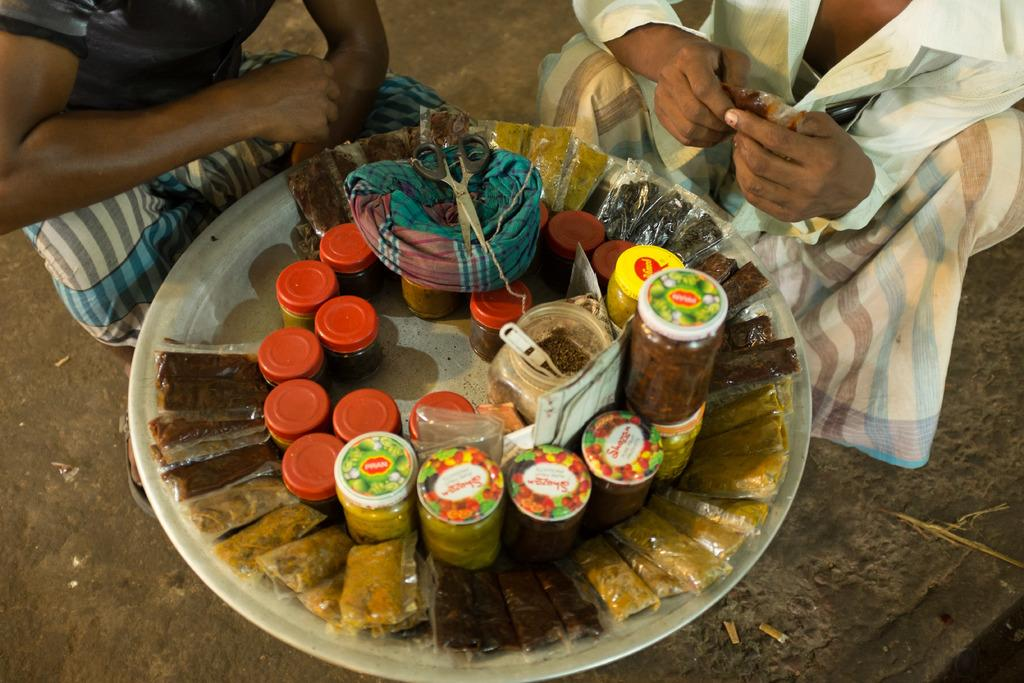What objects are in the foreground of the image? In the foreground of the image, there are sachets, containers, scissors, a cloth, and a metal object. What are the two people in the image doing? The two people in the image are squatting on the ground. What might the scissors be used for in the image? The scissors might be used for cutting or trimming in the image. How many eggs are visible in the image? There are no eggs visible in the image. What part of the wheel is shown in the image? There is no wheel present in the image. 